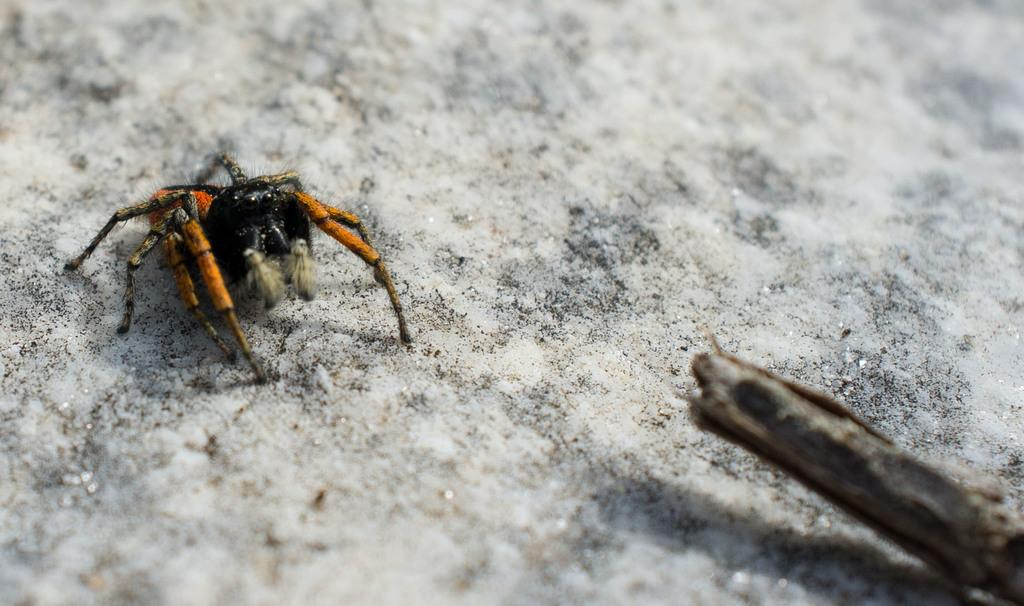What types of creatures can be seen in the image? There are two different insects in the image. What object is located at the bottom of the image? There is a marble at the bottom of the image. What type of cemetery can be seen in the image? There is no cemetery present in the image; it features two insects and a marble. How does the kite fly in the image? There is no kite present in the image. 